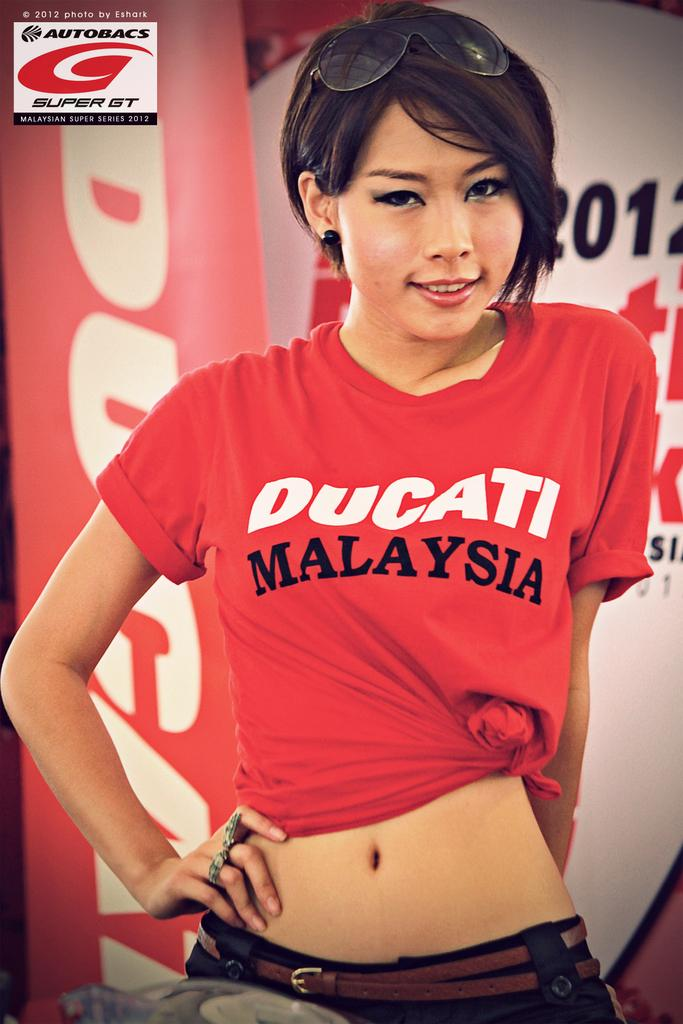<image>
Give a short and clear explanation of the subsequent image. A model wears a Ducati Malaysia tee shirt. 